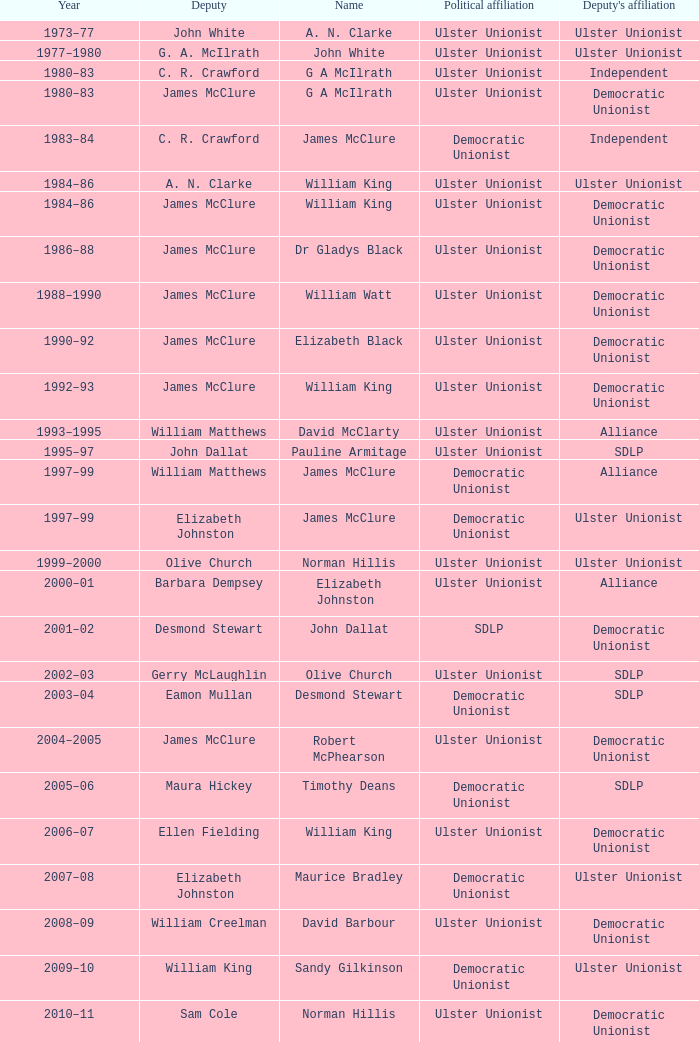What political party does deputy john dallat belong to? Ulster Unionist. 